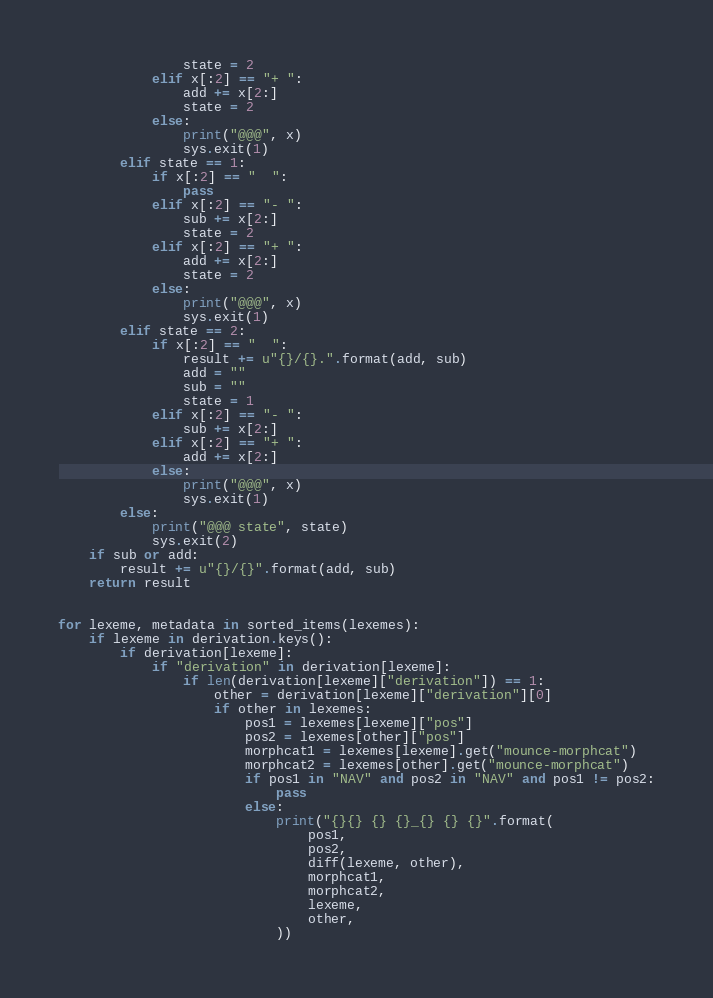Convert code to text. <code><loc_0><loc_0><loc_500><loc_500><_Python_>                state = 2
            elif x[:2] == "+ ":
                add += x[2:]
                state = 2
            else:
                print("@@@", x)
                sys.exit(1)
        elif state == 1:
            if x[:2] == "  ":
                pass
            elif x[:2] == "- ":
                sub += x[2:]
                state = 2
            elif x[:2] == "+ ":
                add += x[2:]
                state = 2
            else:
                print("@@@", x)
                sys.exit(1)
        elif state == 2:
            if x[:2] == "  ":
                result += u"{}/{}.".format(add, sub)
                add = ""
                sub = ""
                state = 1
            elif x[:2] == "- ":
                sub += x[2:]
            elif x[:2] == "+ ":
                add += x[2:]
            else:
                print("@@@", x)
                sys.exit(1)
        else:
            print("@@@ state", state)
            sys.exit(2)
    if sub or add:
        result += u"{}/{}".format(add, sub)
    return result


for lexeme, metadata in sorted_items(lexemes):
    if lexeme in derivation.keys():
        if derivation[lexeme]:
            if "derivation" in derivation[lexeme]:
                if len(derivation[lexeme]["derivation"]) == 1:
                    other = derivation[lexeme]["derivation"][0]
                    if other in lexemes:
                        pos1 = lexemes[lexeme]["pos"]
                        pos2 = lexemes[other]["pos"]
                        morphcat1 = lexemes[lexeme].get("mounce-morphcat")
                        morphcat2 = lexemes[other].get("mounce-morphcat")
                        if pos1 in "NAV" and pos2 in "NAV" and pos1 != pos2:
                            pass
                        else:
                            print("{}{} {} {}_{} {} {}".format(
                                pos1,
                                pos2,
                                diff(lexeme, other),
                                morphcat1,
                                morphcat2,
                                lexeme,
                                other,
                            ))
</code> 